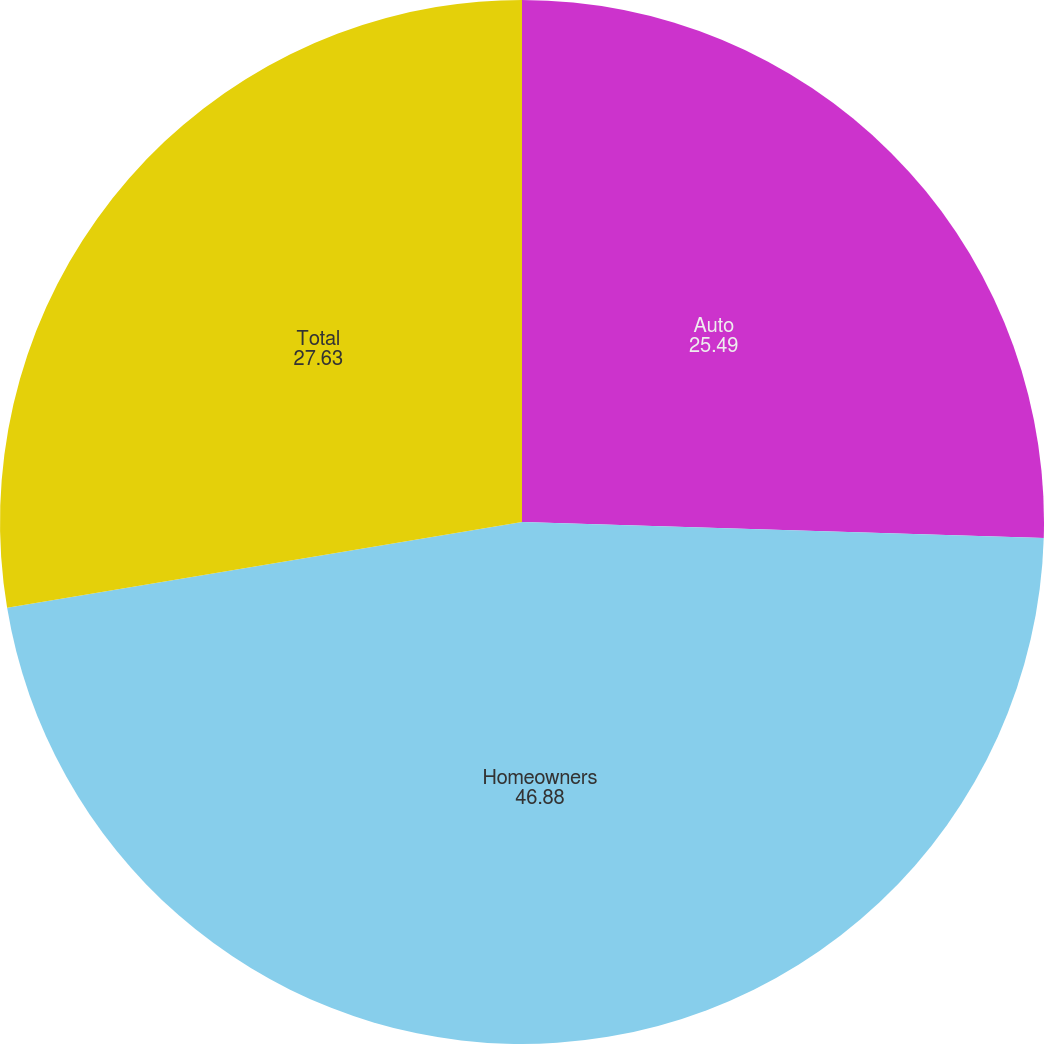Convert chart to OTSL. <chart><loc_0><loc_0><loc_500><loc_500><pie_chart><fcel>Auto<fcel>Homeowners<fcel>Total<nl><fcel>25.49%<fcel>46.88%<fcel>27.63%<nl></chart> 